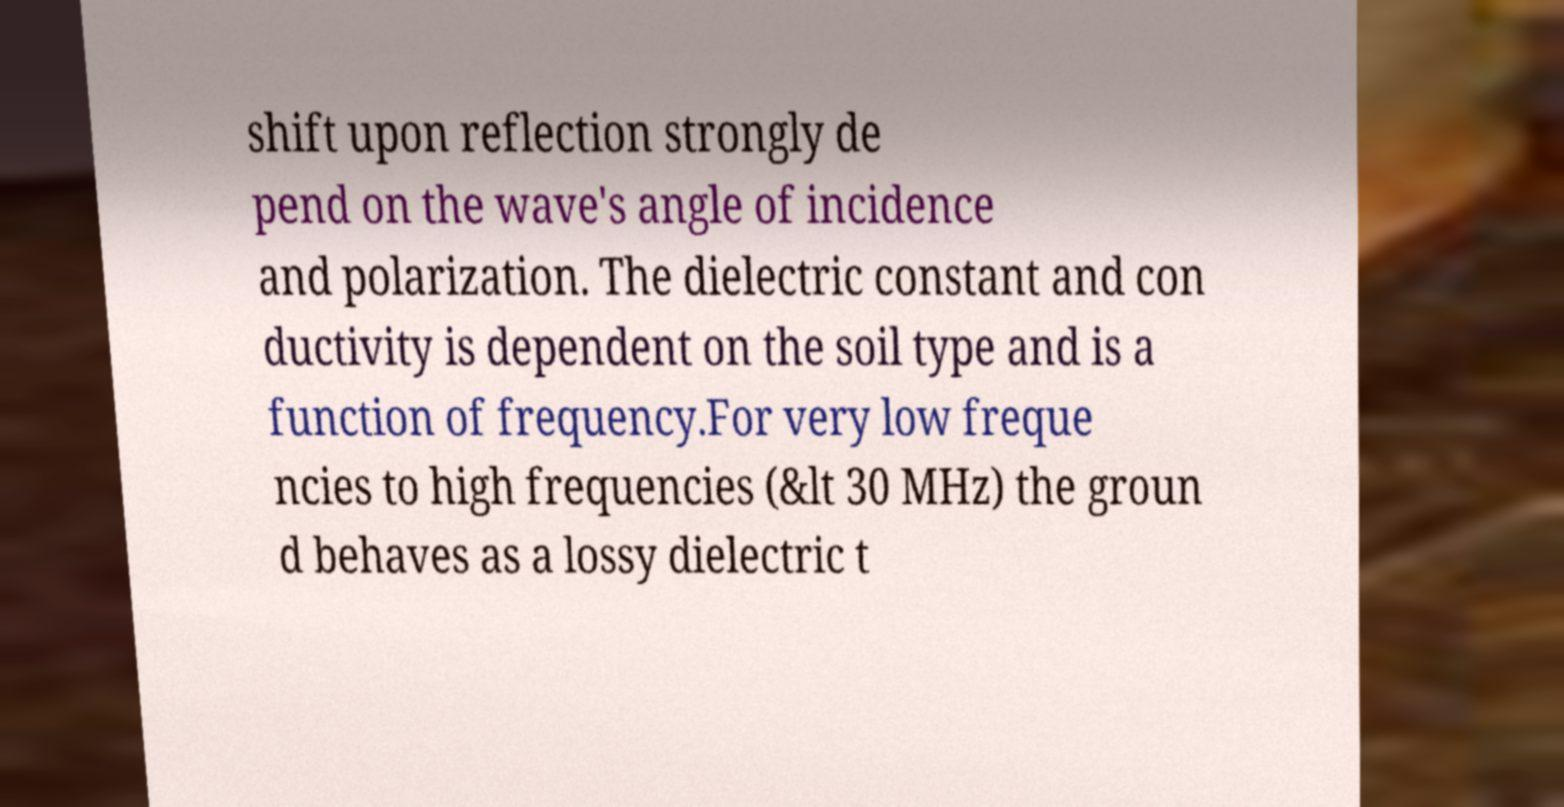I need the written content from this picture converted into text. Can you do that? shift upon reflection strongly de pend on the wave's angle of incidence and polarization. The dielectric constant and con ductivity is dependent on the soil type and is a function of frequency.For very low freque ncies to high frequencies (&lt 30 MHz) the groun d behaves as a lossy dielectric t 